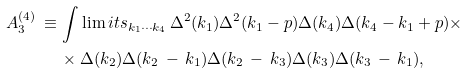Convert formula to latex. <formula><loc_0><loc_0><loc_500><loc_500>A _ { 3 } ^ { ( 4 ) } \, \equiv \, & \int \lim i t s _ { k _ { 1 } \cdots k _ { 4 } } \, \Delta ^ { 2 } ( k _ { 1 } ) \Delta ^ { 2 } ( k _ { 1 } - p ) \Delta ( k _ { 4 } ) \Delta ( k _ { 4 } - k _ { 1 } + p ) \times \\ & \times \Delta ( k _ { 2 } ) \Delta ( k _ { 2 } \, - \, k _ { 1 } ) \Delta ( k _ { 2 } \, - \, k _ { 3 } ) \Delta ( k _ { 3 } ) \Delta ( k _ { 3 } \, - \, k _ { 1 } ) ,</formula> 